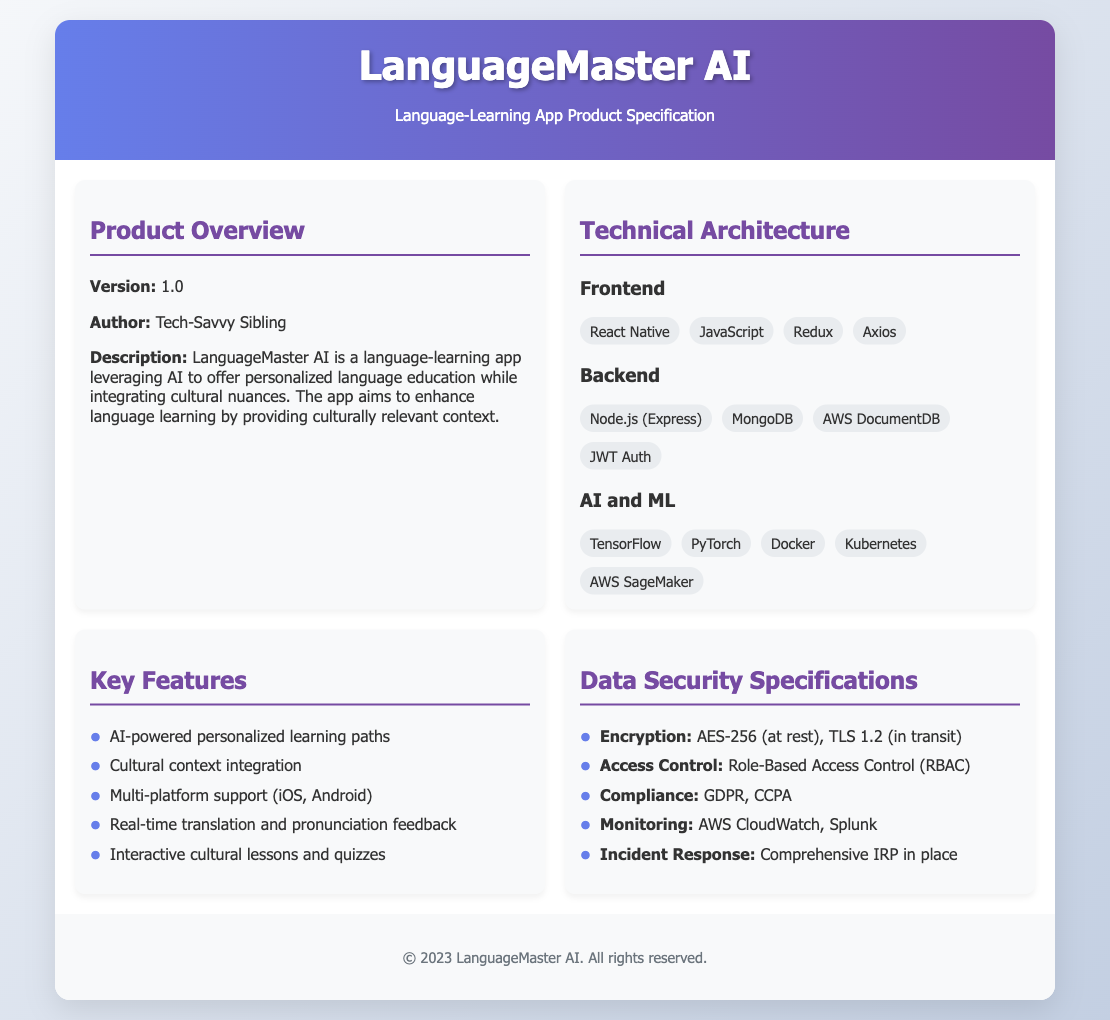what is the version of the app? The version listed in the document is the current release version of the app, which is noted as 1.0.
Answer: 1.0 who is the author of the product specification? The author is mentioned in the product overview section of the document, specifying the creator of this product specification.
Answer: Tech-Savvy Sibling which frontend technology is used? The document lists several technologies under the frontend category; the first mentioned is React Native.
Answer: React Native what compliance regulations does the app meet? The compliance section under data security specifies specific regulations that the app adheres to, which include GDPR and CCPA.
Answer: GDPR, CCPA what is the encryption standard mentioned for data security? The encryption section states the method used to secure data both at rest and in transit, which is AES-256 and TLS 1.2 respectively.
Answer: AES-256, TLS 1.2 how many technologies are listed under AI and ML? The document provides a list of technologies used in the AI and ML section; counting these technologies reveals how many are included.
Answer: 5 what major feature focuses on cultural integration? Among the key features, there's a specific mention of integrating cultural context into the learning paths.
Answer: Cultural context integration what type of access control is implemented? The document specifies the system used for managing access to the app's resources, which is a role-based system.
Answer: Role-Based Access Control which cloud monitoring tools are mentioned? The monitoring section lists specific tools employed for tracking system performance and incidents in the app's architecture, which are AWS CloudWatch and Splunk.
Answer: AWS CloudWatch, Splunk 